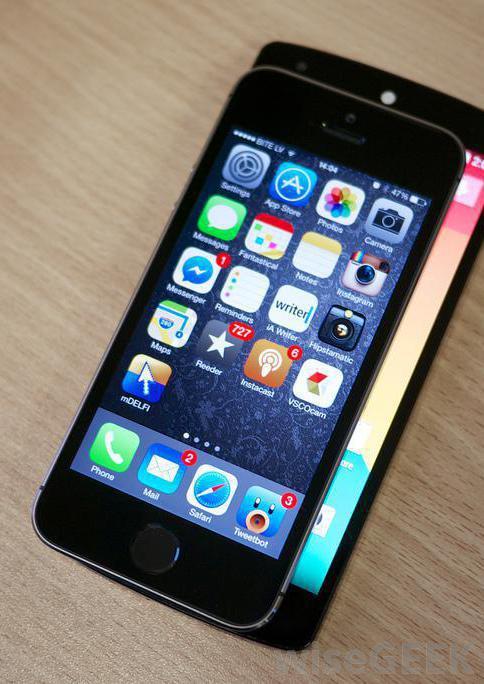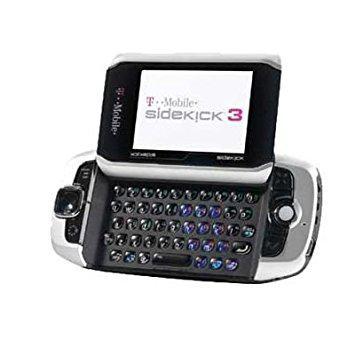The first image is the image on the left, the second image is the image on the right. For the images displayed, is the sentence "In at least one image a there is a single phone with physical buttons on the bottom half of the phone that is attached to a phone screen that is long left to right than up and down." factually correct? Answer yes or no. Yes. The first image is the image on the left, the second image is the image on the right. Examine the images to the left and right. Is the description "One image shows a device with a flipped up horizontal, wide screen with something displaying on the screen." accurate? Answer yes or no. Yes. 